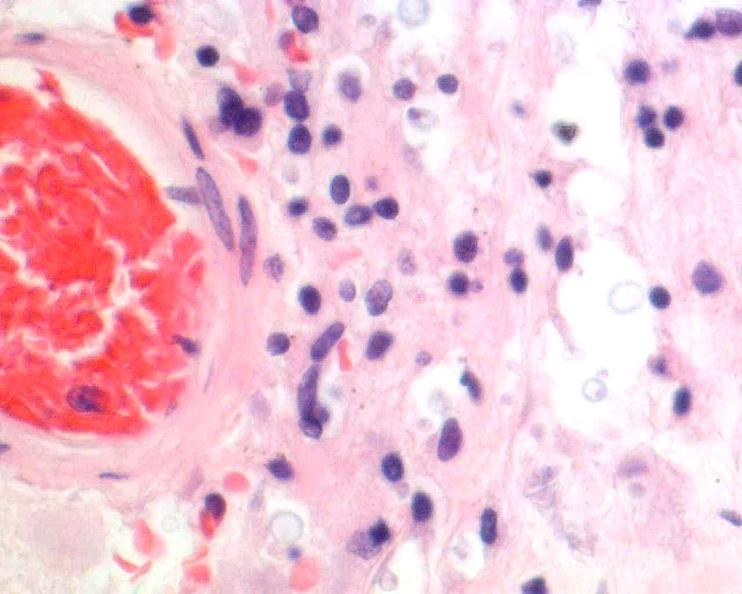where is this?
Answer the question using a single word or phrase. Nervous 